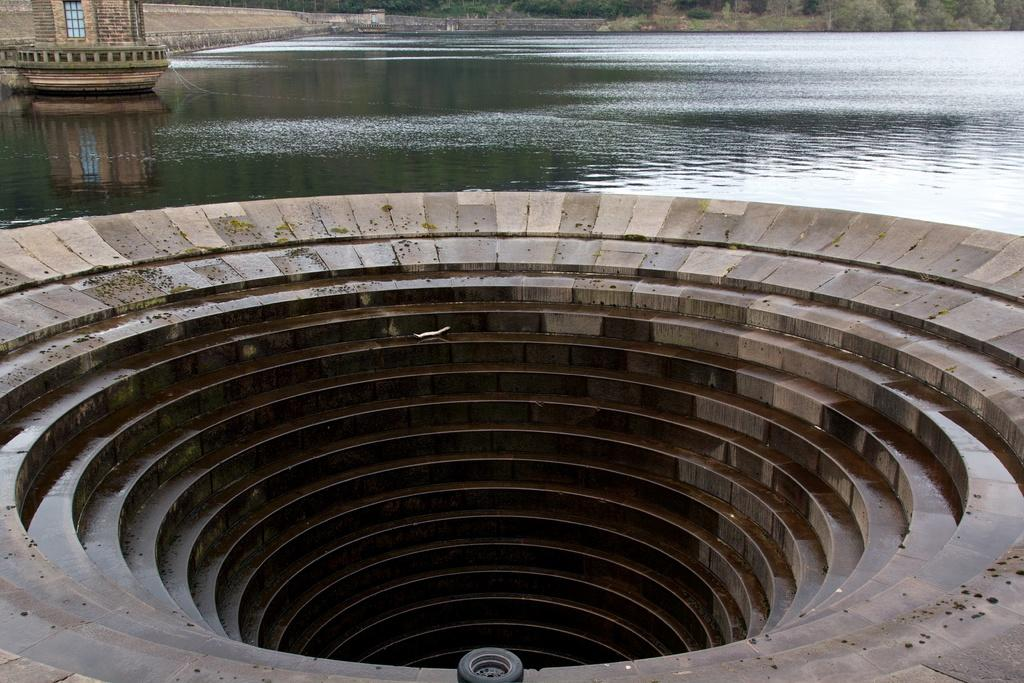What type of structure is present in the image? There is a staircase in the image. Can you describe the shape of the staircase? The staircase has a circular shape. What can be seen in the middle of the image? There is water in the middle of the image. Is there any indication of an interior space in the image? There may be a room on the left side of the image. What type of natural scenery is visible at the top of the image? There are trees at the top of the image. What type of jewel is being used to control the water in the image? There is no jewel or control mechanism present in the image; it simply shows a staircase, water, and trees. 